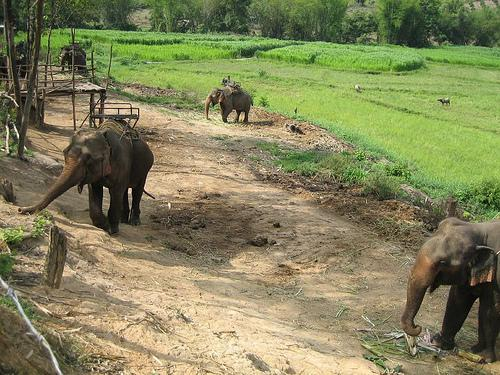Question: when was this photo taken?
Choices:
A. During the day.
B. In the evening.
C. At night.
D. Morning.
Answer with the letter. Answer: A Question: what color is the dirt?
Choices:
A. Red.
B. Black.
C. Grey.
D. Brown.
Answer with the letter. Answer: D Question: who is the subject of the photo?
Choices:
A. The baby.
B. The horses.
C. The elephants.
D. The flower garden.
Answer with the letter. Answer: C Question: how many elephants are there?
Choices:
A. 3.
B. 5.
C. 6.
D. 4.
Answer with the letter. Answer: D Question: what color are the elephants?
Choices:
A. Gray.
B. Brown.
C. White.
D. Black.
Answer with the letter. Answer: A Question: why is this photo illuminated?
Choices:
A. Ceiling light is on.
B. Lamp.
C. Sunlight.
D. Flashlight is on.
Answer with the letter. Answer: C Question: where was this photo taken?
Choices:
A. New York.
B. Savannah.
C. Atlanta.
D. At work.
Answer with the letter. Answer: B 